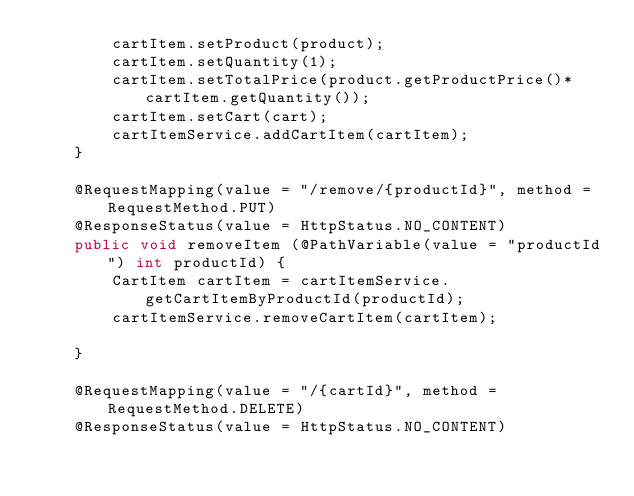Convert code to text. <code><loc_0><loc_0><loc_500><loc_500><_Java_>        cartItem.setProduct(product);
        cartItem.setQuantity(1);
        cartItem.setTotalPrice(product.getProductPrice()*cartItem.getQuantity());
        cartItem.setCart(cart);
        cartItemService.addCartItem(cartItem);
    }

    @RequestMapping(value = "/remove/{productId}", method = RequestMethod.PUT)
    @ResponseStatus(value = HttpStatus.NO_CONTENT)
    public void removeItem (@PathVariable(value = "productId") int productId) {
        CartItem cartItem = cartItemService.getCartItemByProductId(productId);
        cartItemService.removeCartItem(cartItem);

    }

    @RequestMapping(value = "/{cartId}", method = RequestMethod.DELETE)
    @ResponseStatus(value = HttpStatus.NO_CONTENT)</code> 